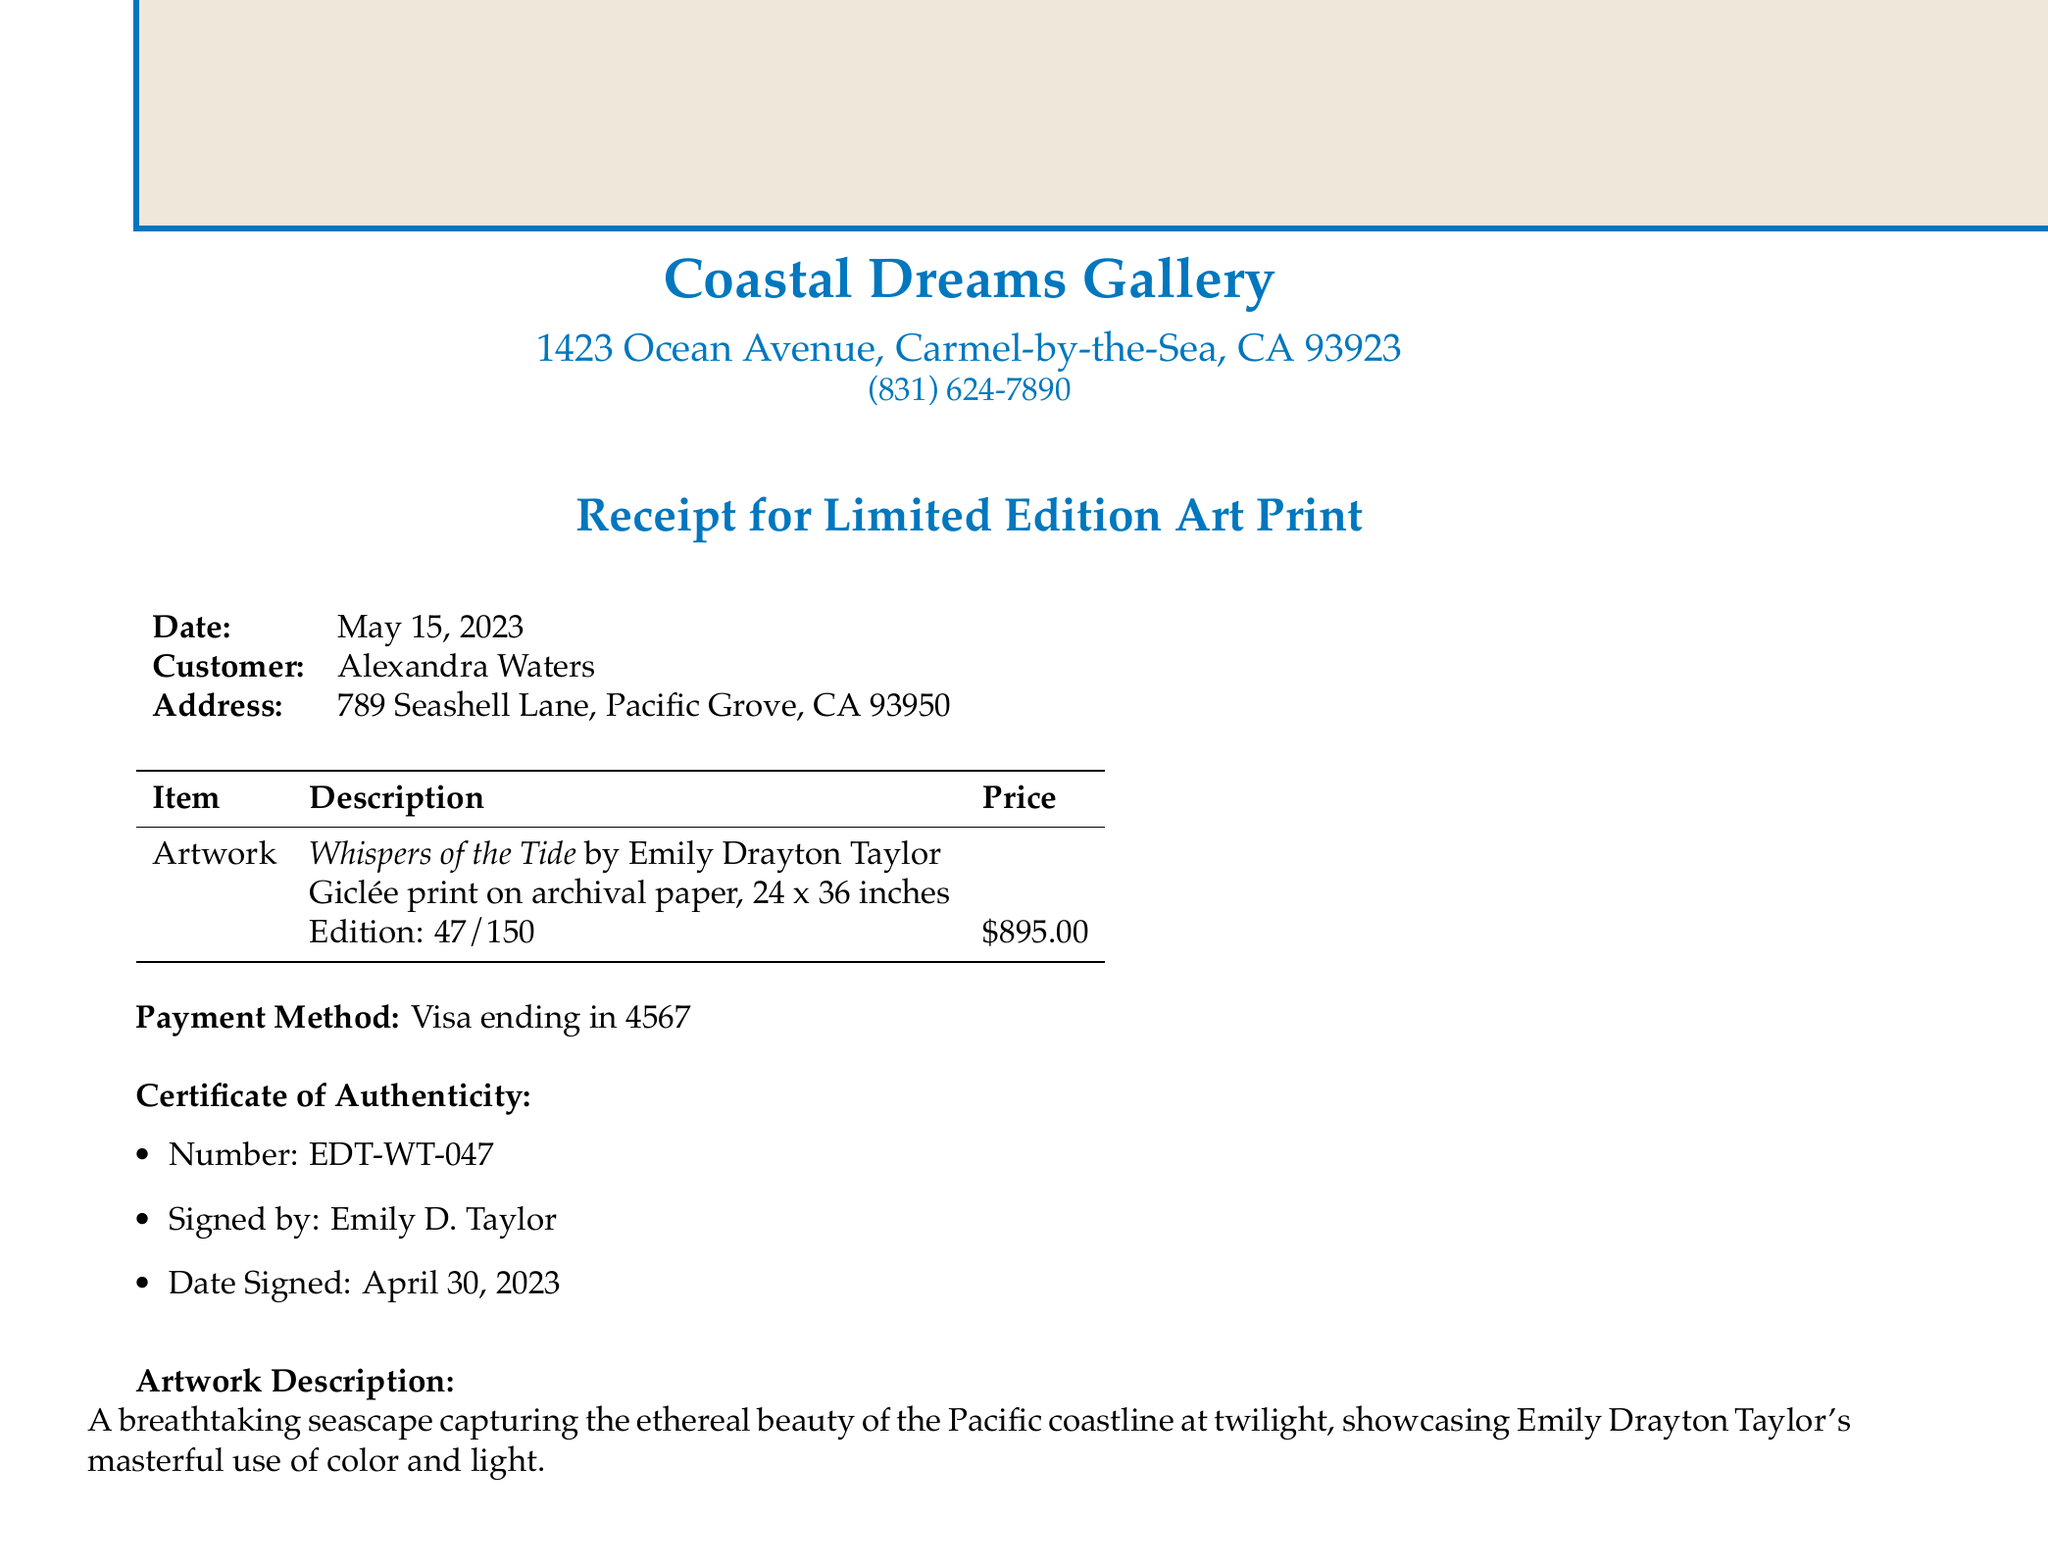what is the artist's name? The artist's name is clearly mentioned at the top of the document.
Answer: Emily Drayton Taylor what is the edition number of the artwork? The edition number is specified under the artwork details section in the receipt.
Answer: 47/150 what is the price of the art print? The price is listed prominently in the purchase details of the receipt.
Answer: $895.00 when was the artwork signed by the artist? The date signed is indicated in the certificate of authenticity section of the document.
Answer: April 30, 2023 who is the customer? The customer's name is provided at the beginning of the receipt.
Answer: Alexandra Waters what is the medium of the artwork? The medium is described as part of the details about the artwork.
Answer: Giclée print on archival paper how will the artwork be shipped? The shipping method is outlined in the shipping section of the document.
Answer: Insured art courier service what is the return policy for the artwork? The return policy is stated near the end of the document.
Answer: 30-day return policy where is the gallery located? The address of the gallery is mentioned at the top of the receipt.
Answer: 1423 Ocean Avenue, Carmel-by-the-Sea, CA 93923 